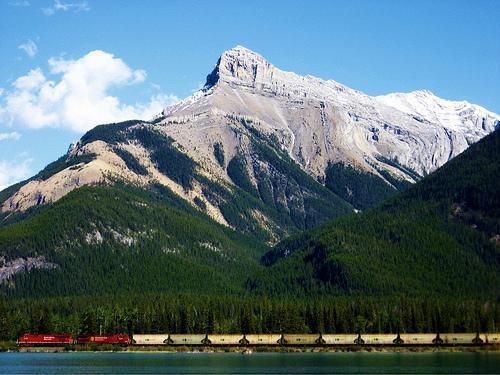How many train cars are red?
Give a very brief answer. 2. How many total train cars are there?
Give a very brief answer. 12. How many trains are in this photo?
Give a very brief answer. 1. How many red train cars are in the picture?
Give a very brief answer. 2. 